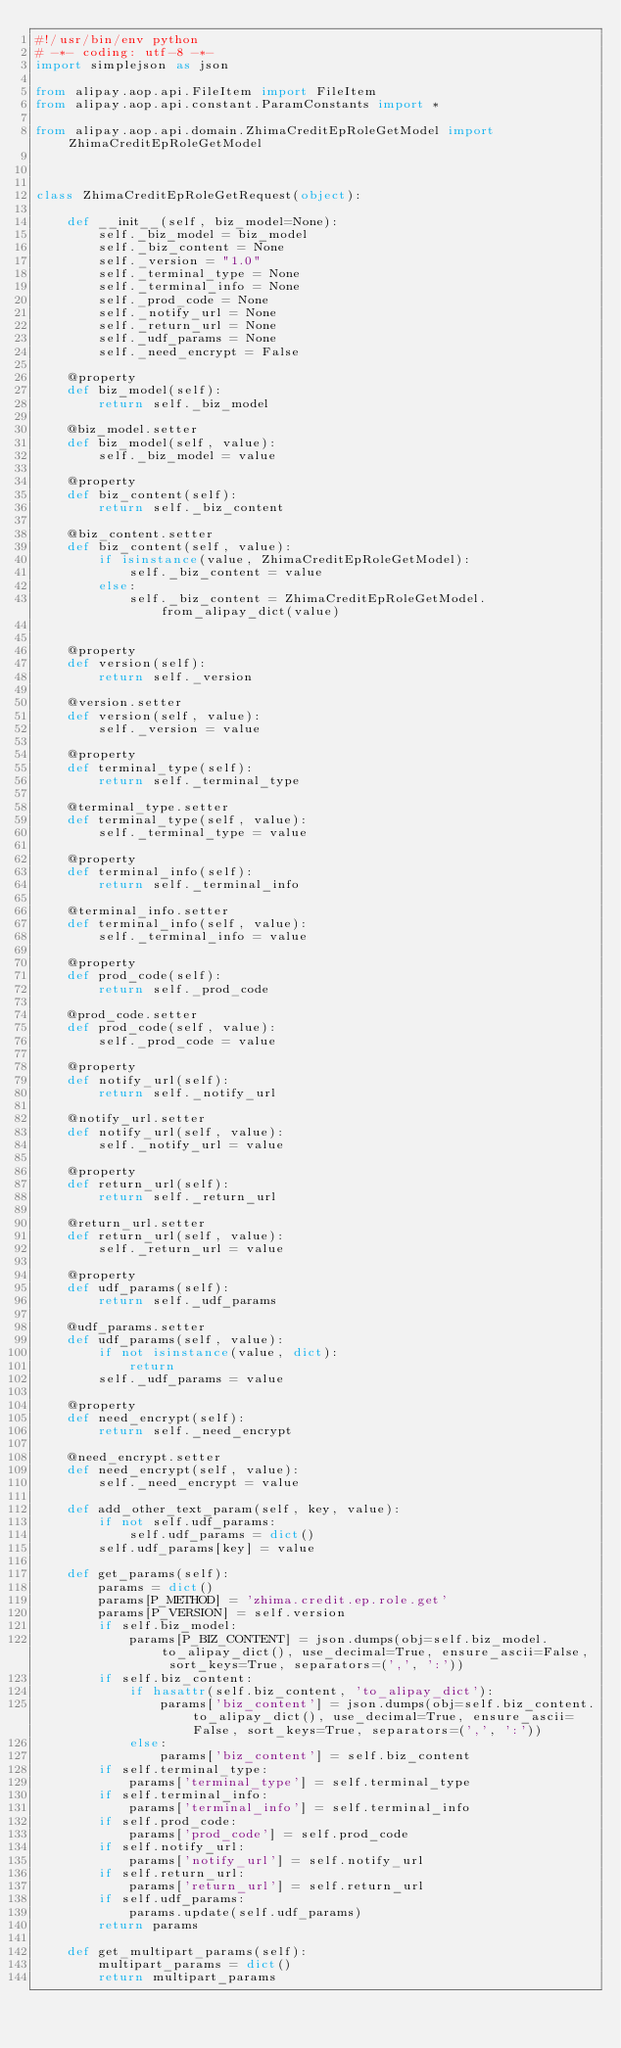<code> <loc_0><loc_0><loc_500><loc_500><_Python_>#!/usr/bin/env python
# -*- coding: utf-8 -*-
import simplejson as json

from alipay.aop.api.FileItem import FileItem
from alipay.aop.api.constant.ParamConstants import *

from alipay.aop.api.domain.ZhimaCreditEpRoleGetModel import ZhimaCreditEpRoleGetModel



class ZhimaCreditEpRoleGetRequest(object):

    def __init__(self, biz_model=None):
        self._biz_model = biz_model
        self._biz_content = None
        self._version = "1.0"
        self._terminal_type = None
        self._terminal_info = None
        self._prod_code = None
        self._notify_url = None
        self._return_url = None
        self._udf_params = None
        self._need_encrypt = False

    @property
    def biz_model(self):
        return self._biz_model

    @biz_model.setter
    def biz_model(self, value):
        self._biz_model = value

    @property
    def biz_content(self):
        return self._biz_content

    @biz_content.setter
    def biz_content(self, value):
        if isinstance(value, ZhimaCreditEpRoleGetModel):
            self._biz_content = value
        else:
            self._biz_content = ZhimaCreditEpRoleGetModel.from_alipay_dict(value)


    @property
    def version(self):
        return self._version

    @version.setter
    def version(self, value):
        self._version = value

    @property
    def terminal_type(self):
        return self._terminal_type

    @terminal_type.setter
    def terminal_type(self, value):
        self._terminal_type = value

    @property
    def terminal_info(self):
        return self._terminal_info

    @terminal_info.setter
    def terminal_info(self, value):
        self._terminal_info = value

    @property
    def prod_code(self):
        return self._prod_code

    @prod_code.setter
    def prod_code(self, value):
        self._prod_code = value

    @property
    def notify_url(self):
        return self._notify_url

    @notify_url.setter
    def notify_url(self, value):
        self._notify_url = value

    @property
    def return_url(self):
        return self._return_url

    @return_url.setter
    def return_url(self, value):
        self._return_url = value

    @property
    def udf_params(self):
        return self._udf_params

    @udf_params.setter
    def udf_params(self, value):
        if not isinstance(value, dict):
            return
        self._udf_params = value

    @property
    def need_encrypt(self):
        return self._need_encrypt

    @need_encrypt.setter
    def need_encrypt(self, value):
        self._need_encrypt = value

    def add_other_text_param(self, key, value):
        if not self.udf_params:
            self.udf_params = dict()
        self.udf_params[key] = value

    def get_params(self):
        params = dict()
        params[P_METHOD] = 'zhima.credit.ep.role.get'
        params[P_VERSION] = self.version
        if self.biz_model:
            params[P_BIZ_CONTENT] = json.dumps(obj=self.biz_model.to_alipay_dict(), use_decimal=True, ensure_ascii=False, sort_keys=True, separators=(',', ':'))
        if self.biz_content:
            if hasattr(self.biz_content, 'to_alipay_dict'):
                params['biz_content'] = json.dumps(obj=self.biz_content.to_alipay_dict(), use_decimal=True, ensure_ascii=False, sort_keys=True, separators=(',', ':'))
            else:
                params['biz_content'] = self.biz_content
        if self.terminal_type:
            params['terminal_type'] = self.terminal_type
        if self.terminal_info:
            params['terminal_info'] = self.terminal_info
        if self.prod_code:
            params['prod_code'] = self.prod_code
        if self.notify_url:
            params['notify_url'] = self.notify_url
        if self.return_url:
            params['return_url'] = self.return_url
        if self.udf_params:
            params.update(self.udf_params)
        return params

    def get_multipart_params(self):
        multipart_params = dict()
        return multipart_params
</code> 